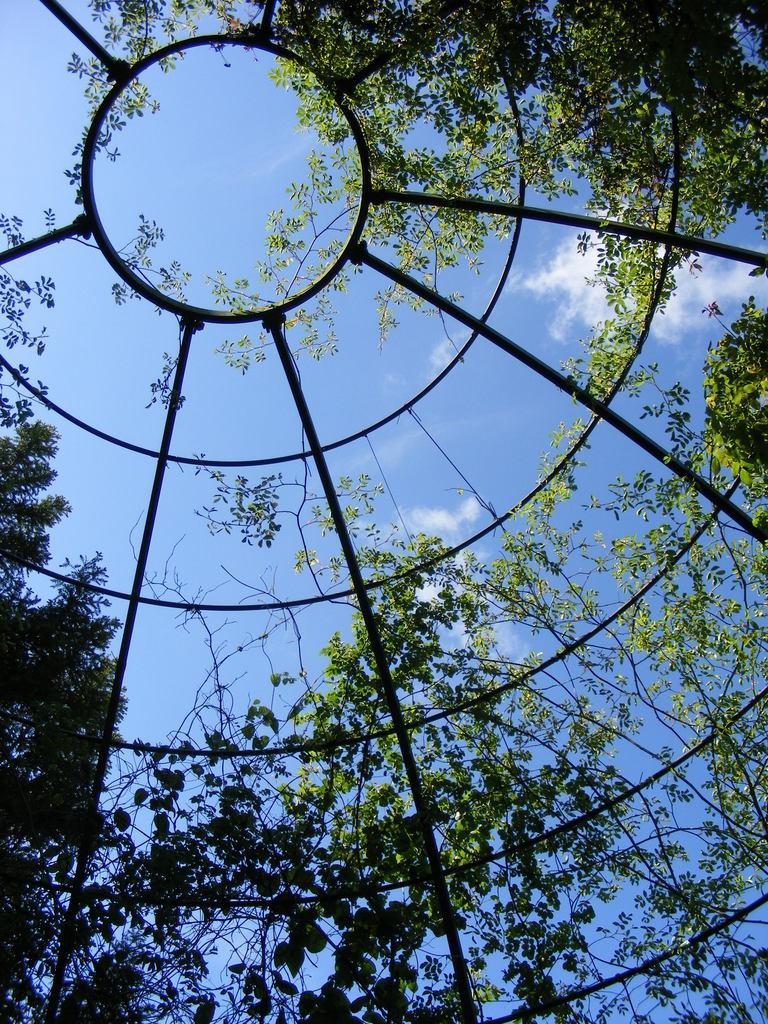What type of structure is visible in the image? There is an iron pole construction in the image. What else can be seen in the image besides the iron pole construction? There are plants in the image. What is visible in the background of the image? The sky is visible in the image. Can you describe the sky in the image? Clouds are present in the sky. Where can the market be found in the image? There is no market present in the image. What type of underwear is hanging on the iron pole construction? There is no underwear visible in the image. 